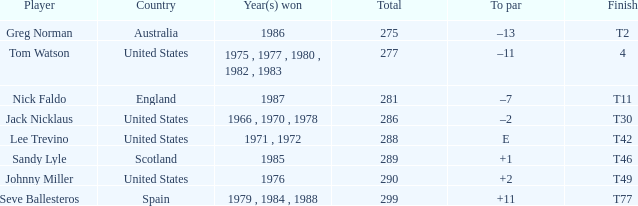Parse the table in full. {'header': ['Player', 'Country', 'Year(s) won', 'Total', 'To par', 'Finish'], 'rows': [['Greg Norman', 'Australia', '1986', '275', '–13', 'T2'], ['Tom Watson', 'United States', '1975 , 1977 , 1980 , 1982 , 1983', '277', '–11', '4'], ['Nick Faldo', 'England', '1987', '281', '–7', 'T11'], ['Jack Nicklaus', 'United States', '1966 , 1970 , 1978', '286', '–2', 'T30'], ['Lee Trevino', 'United States', '1971 , 1972', '288', 'E', 'T42'], ['Sandy Lyle', 'Scotland', '1985', '289', '+1', 'T46'], ['Johnny Miller', 'United States', '1976', '290', '+2', 'T49'], ['Seve Ballesteros', 'Spain', '1979 , 1984 , 1988', '299', '+11', 'T77']]} What country had a finish of t49? United States. 